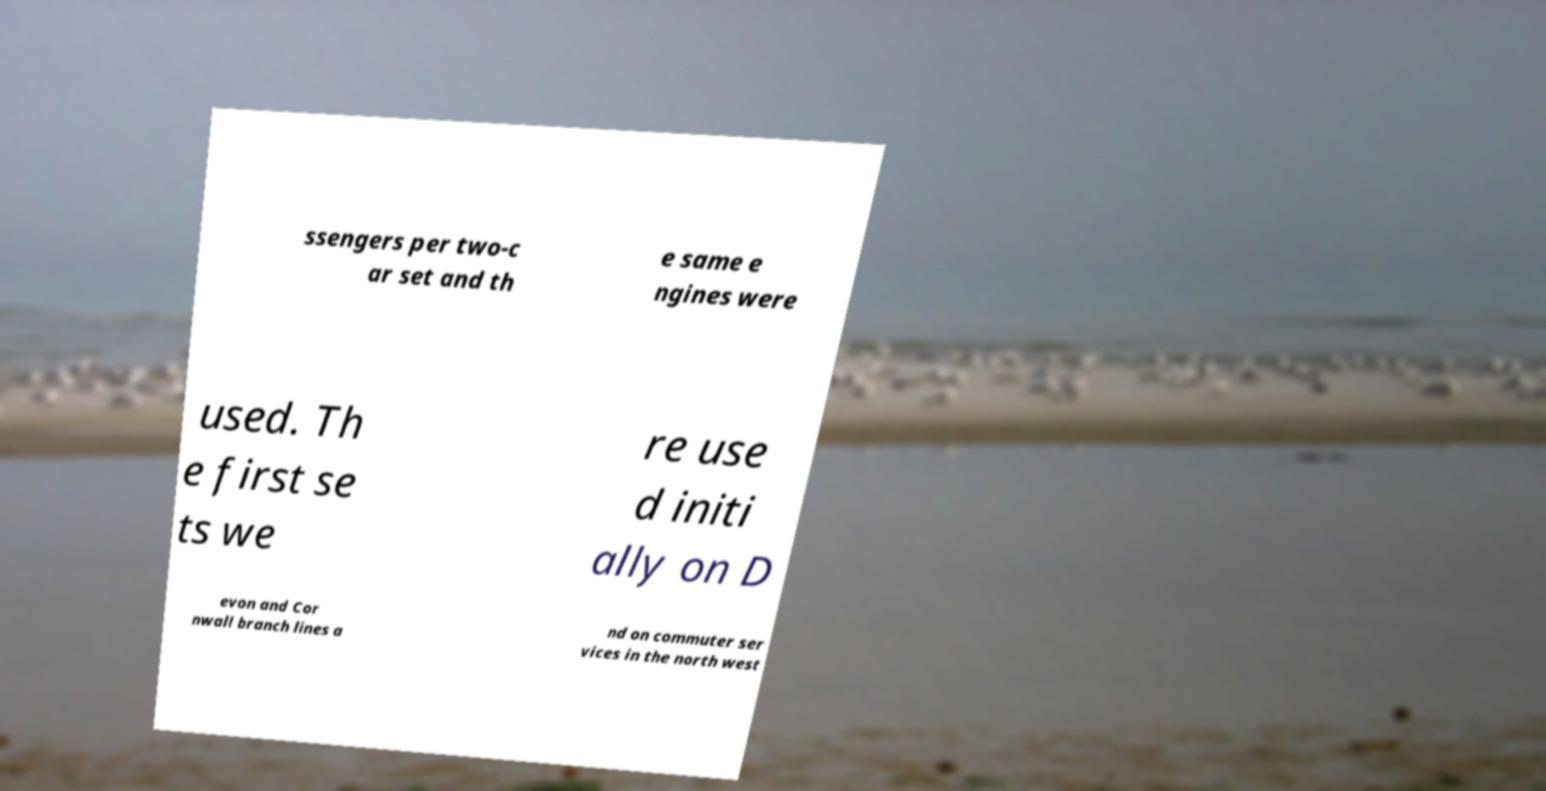Could you extract and type out the text from this image? ssengers per two-c ar set and th e same e ngines were used. Th e first se ts we re use d initi ally on D evon and Cor nwall branch lines a nd on commuter ser vices in the north west 